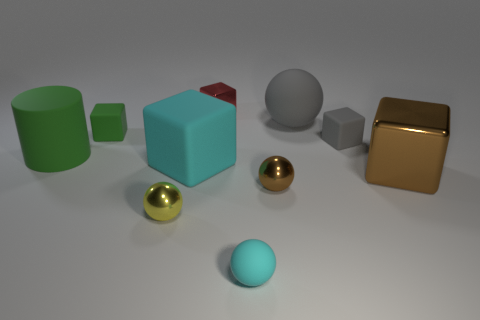What is the shape of the tiny metal object that is on the right side of the yellow thing and in front of the red cube?
Offer a very short reply. Sphere. How many other objects are the same shape as the large green thing?
Offer a very short reply. 0. What is the color of the shiny block that is the same size as the yellow sphere?
Give a very brief answer. Red. How many objects are either purple cubes or gray rubber blocks?
Provide a short and direct response. 1. There is a small green object; are there any blocks in front of it?
Keep it short and to the point. Yes. Are there any big cyan cubes made of the same material as the red cube?
Provide a succinct answer. No. What is the size of the rubber block that is the same color as the large matte sphere?
Make the answer very short. Small. What number of cylinders are either green matte objects or small red things?
Provide a succinct answer. 1. Are there more small yellow metal balls that are behind the green rubber cylinder than brown metallic balls behind the big cyan block?
Ensure brevity in your answer.  No. What number of tiny balls are the same color as the cylinder?
Your answer should be very brief. 0. 